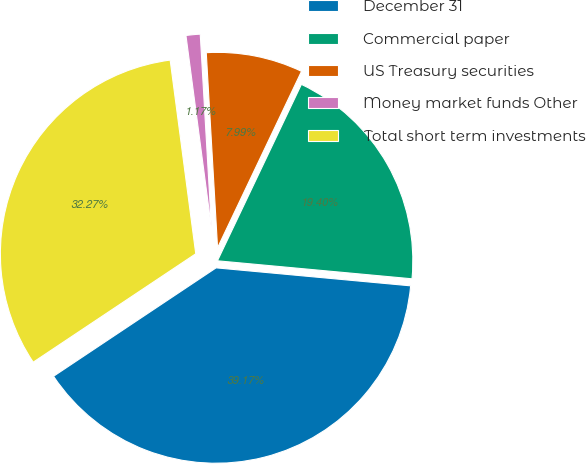Convert chart to OTSL. <chart><loc_0><loc_0><loc_500><loc_500><pie_chart><fcel>December 31<fcel>Commercial paper<fcel>US Treasury securities<fcel>Money market funds Other<fcel>Total short term investments<nl><fcel>39.17%<fcel>19.4%<fcel>7.99%<fcel>1.17%<fcel>32.27%<nl></chart> 